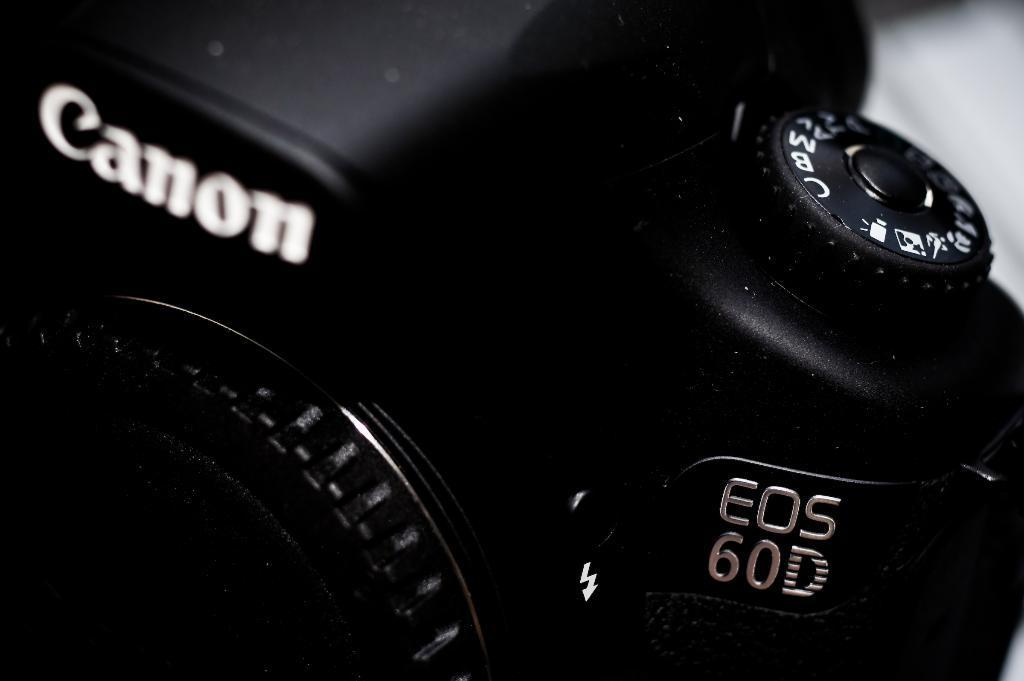Please provide a concise description of this image. In this image I can see a camera in black color. 